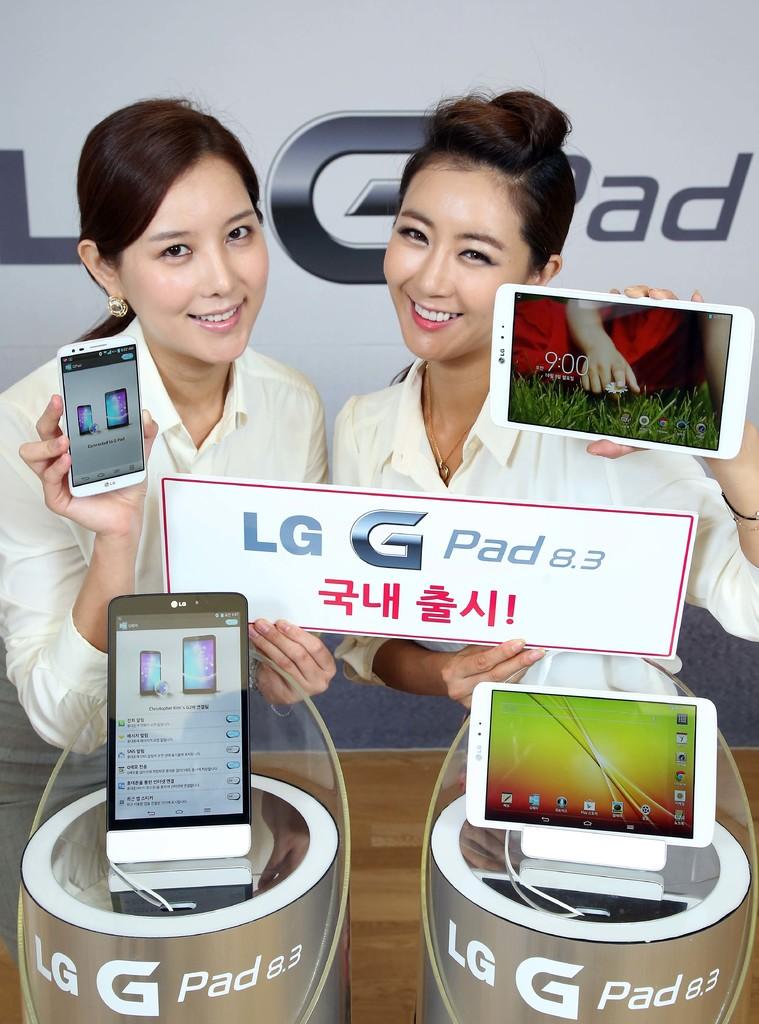What brand of phones and tablets are they?
Keep it short and to the point. Lg. What version number is the lg pad?
Offer a very short reply. 8.3. 